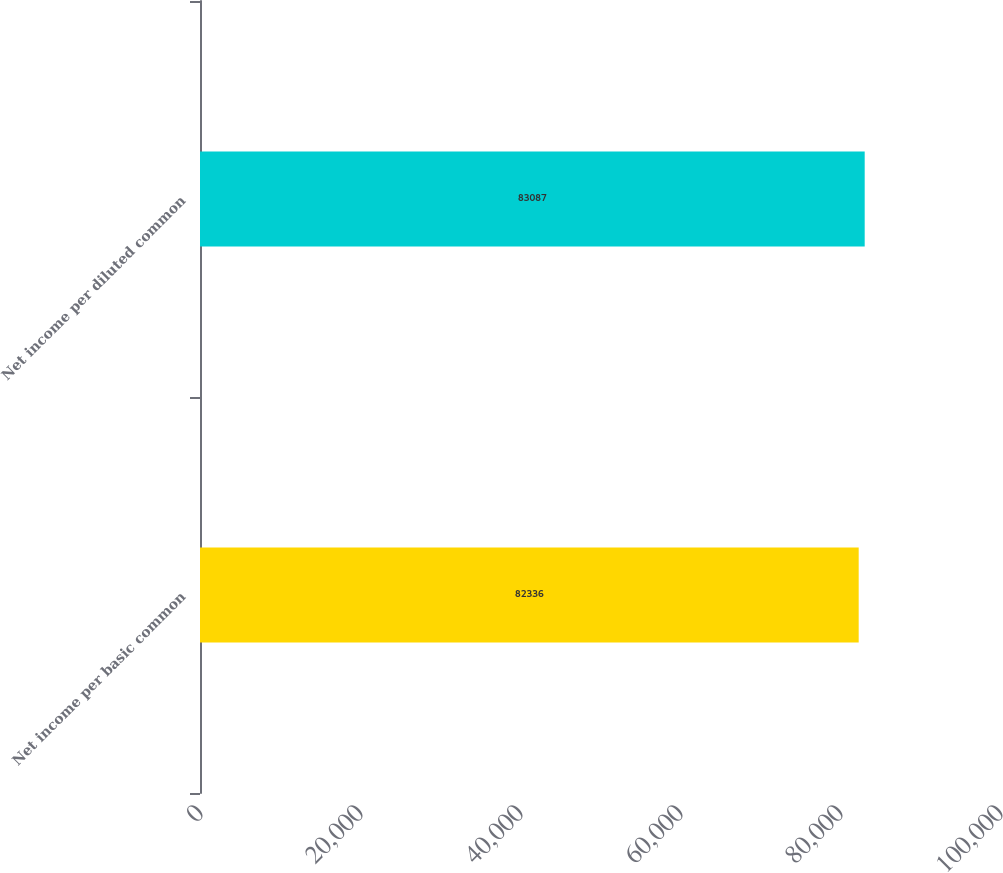Convert chart to OTSL. <chart><loc_0><loc_0><loc_500><loc_500><bar_chart><fcel>Net income per basic common<fcel>Net income per diluted common<nl><fcel>82336<fcel>83087<nl></chart> 